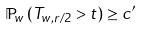Convert formula to latex. <formula><loc_0><loc_0><loc_500><loc_500>\mathbb { P } _ { w } \left ( T _ { w , r / 2 } > t \right ) \geq c ^ { \prime }</formula> 